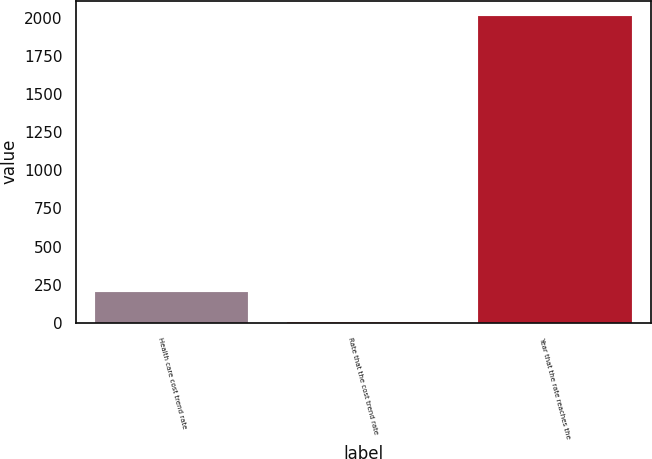Convert chart. <chart><loc_0><loc_0><loc_500><loc_500><bar_chart><fcel>Health care cost trend rate<fcel>Rate that the cost trend rate<fcel>Year that the rate reaches the<nl><fcel>205.6<fcel>5<fcel>2011<nl></chart> 